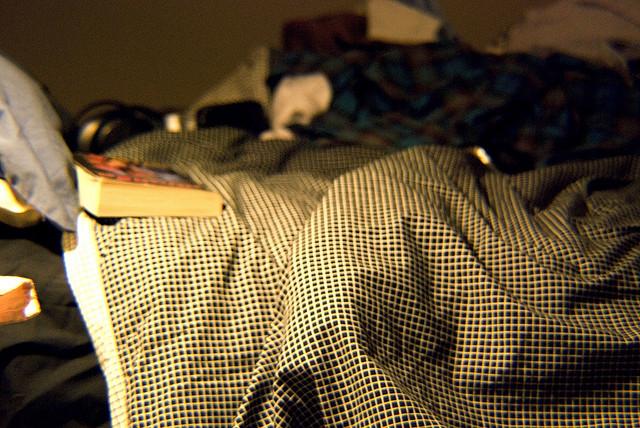Is the book's title obvious?
Be succinct. No. What pattern is the sheet?
Quick response, please. Checkered. What is the book laying on?
Give a very brief answer. Bed. 